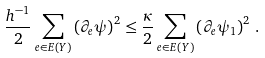<formula> <loc_0><loc_0><loc_500><loc_500>\frac { h ^ { - 1 } } { 2 } \sum _ { e \in E ( Y ) } \left ( \partial _ { e } \psi \right ) ^ { 2 } \leq \frac { \kappa } { 2 } \sum _ { e \in E ( Y ) } \left ( \partial _ { e } \psi _ { 1 } \right ) ^ { 2 } \, .</formula> 